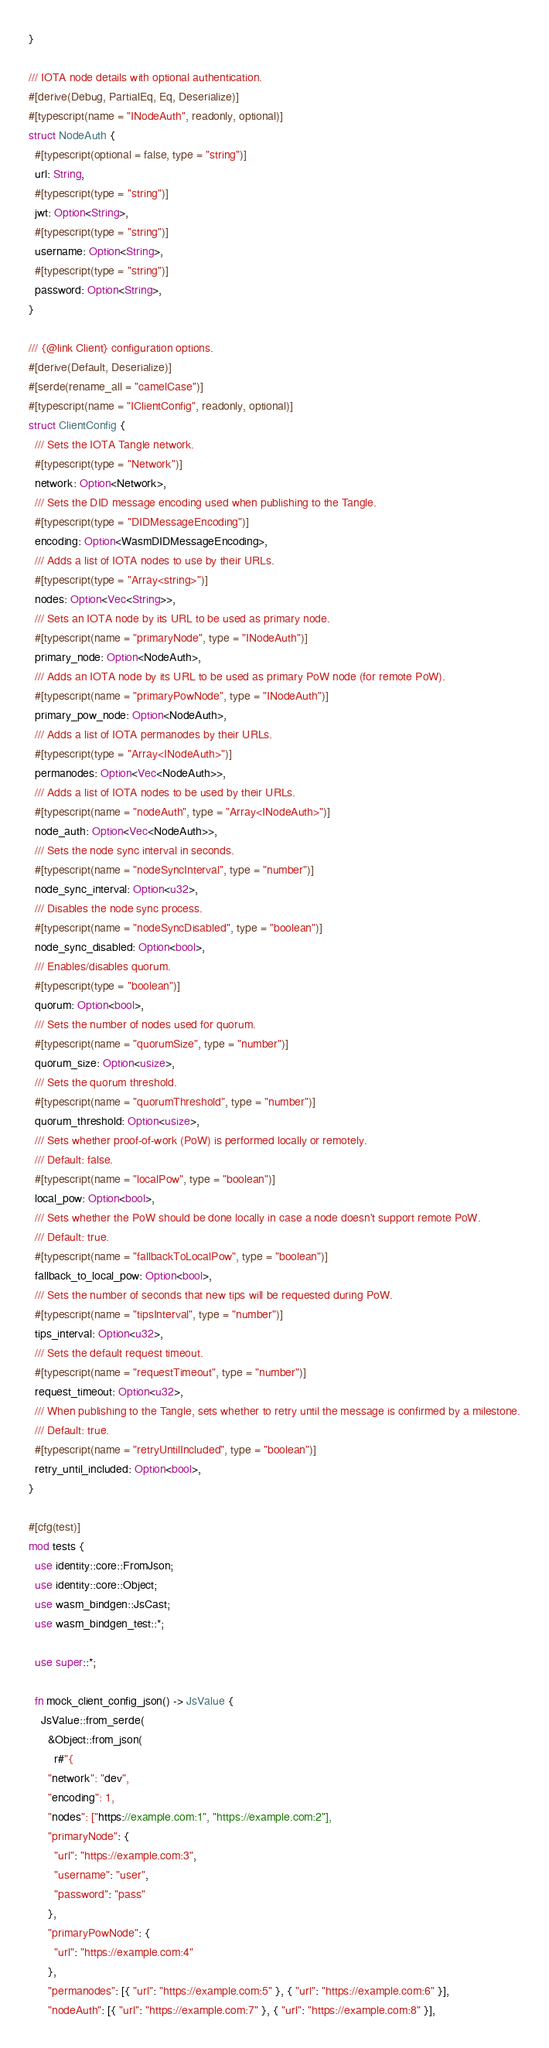Convert code to text. <code><loc_0><loc_0><loc_500><loc_500><_Rust_>}

/// IOTA node details with optional authentication.
#[derive(Debug, PartialEq, Eq, Deserialize)]
#[typescript(name = "INodeAuth", readonly, optional)]
struct NodeAuth {
  #[typescript(optional = false, type = "string")]
  url: String,
  #[typescript(type = "string")]
  jwt: Option<String>,
  #[typescript(type = "string")]
  username: Option<String>,
  #[typescript(type = "string")]
  password: Option<String>,
}

/// {@link Client} configuration options.
#[derive(Default, Deserialize)]
#[serde(rename_all = "camelCase")]
#[typescript(name = "IClientConfig", readonly, optional)]
struct ClientConfig {
  /// Sets the IOTA Tangle network.
  #[typescript(type = "Network")]
  network: Option<Network>,
  /// Sets the DID message encoding used when publishing to the Tangle.
  #[typescript(type = "DIDMessageEncoding")]
  encoding: Option<WasmDIDMessageEncoding>,
  /// Adds a list of IOTA nodes to use by their URLs.
  #[typescript(type = "Array<string>")]
  nodes: Option<Vec<String>>,
  /// Sets an IOTA node by its URL to be used as primary node.
  #[typescript(name = "primaryNode", type = "INodeAuth")]
  primary_node: Option<NodeAuth>,
  /// Adds an IOTA node by its URL to be used as primary PoW node (for remote PoW).
  #[typescript(name = "primaryPowNode", type = "INodeAuth")]
  primary_pow_node: Option<NodeAuth>,
  /// Adds a list of IOTA permanodes by their URLs.
  #[typescript(type = "Array<INodeAuth>")]
  permanodes: Option<Vec<NodeAuth>>,
  /// Adds a list of IOTA nodes to be used by their URLs.
  #[typescript(name = "nodeAuth", type = "Array<INodeAuth>")]
  node_auth: Option<Vec<NodeAuth>>,
  /// Sets the node sync interval in seconds.
  #[typescript(name = "nodeSyncInterval", type = "number")]
  node_sync_interval: Option<u32>,
  /// Disables the node sync process.
  #[typescript(name = "nodeSyncDisabled", type = "boolean")]
  node_sync_disabled: Option<bool>,
  /// Enables/disables quorum.
  #[typescript(type = "boolean")]
  quorum: Option<bool>,
  /// Sets the number of nodes used for quorum.
  #[typescript(name = "quorumSize", type = "number")]
  quorum_size: Option<usize>,
  /// Sets the quorum threshold.
  #[typescript(name = "quorumThreshold", type = "number")]
  quorum_threshold: Option<usize>,
  /// Sets whether proof-of-work (PoW) is performed locally or remotely.
  /// Default: false.
  #[typescript(name = "localPow", type = "boolean")]
  local_pow: Option<bool>,
  /// Sets whether the PoW should be done locally in case a node doesn't support remote PoW.
  /// Default: true.
  #[typescript(name = "fallbackToLocalPow", type = "boolean")]
  fallback_to_local_pow: Option<bool>,
  /// Sets the number of seconds that new tips will be requested during PoW.
  #[typescript(name = "tipsInterval", type = "number")]
  tips_interval: Option<u32>,
  /// Sets the default request timeout.
  #[typescript(name = "requestTimeout", type = "number")]
  request_timeout: Option<u32>,
  /// When publishing to the Tangle, sets whether to retry until the message is confirmed by a milestone.
  /// Default: true.
  #[typescript(name = "retryUntilIncluded", type = "boolean")]
  retry_until_included: Option<bool>,
}

#[cfg(test)]
mod tests {
  use identity::core::FromJson;
  use identity::core::Object;
  use wasm_bindgen::JsCast;
  use wasm_bindgen_test::*;

  use super::*;

  fn mock_client_config_json() -> JsValue {
    JsValue::from_serde(
      &Object::from_json(
        r#"{
      "network": "dev",
      "encoding": 1,
      "nodes": ["https://example.com:1", "https://example.com:2"],
      "primaryNode": {
        "url": "https://example.com:3",
        "username": "user",
        "password": "pass"
      },
      "primaryPowNode": {
        "url": "https://example.com:4"
      },
      "permanodes": [{ "url": "https://example.com:5" }, { "url": "https://example.com:6" }],
      "nodeAuth": [{ "url": "https://example.com:7" }, { "url": "https://example.com:8" }],</code> 